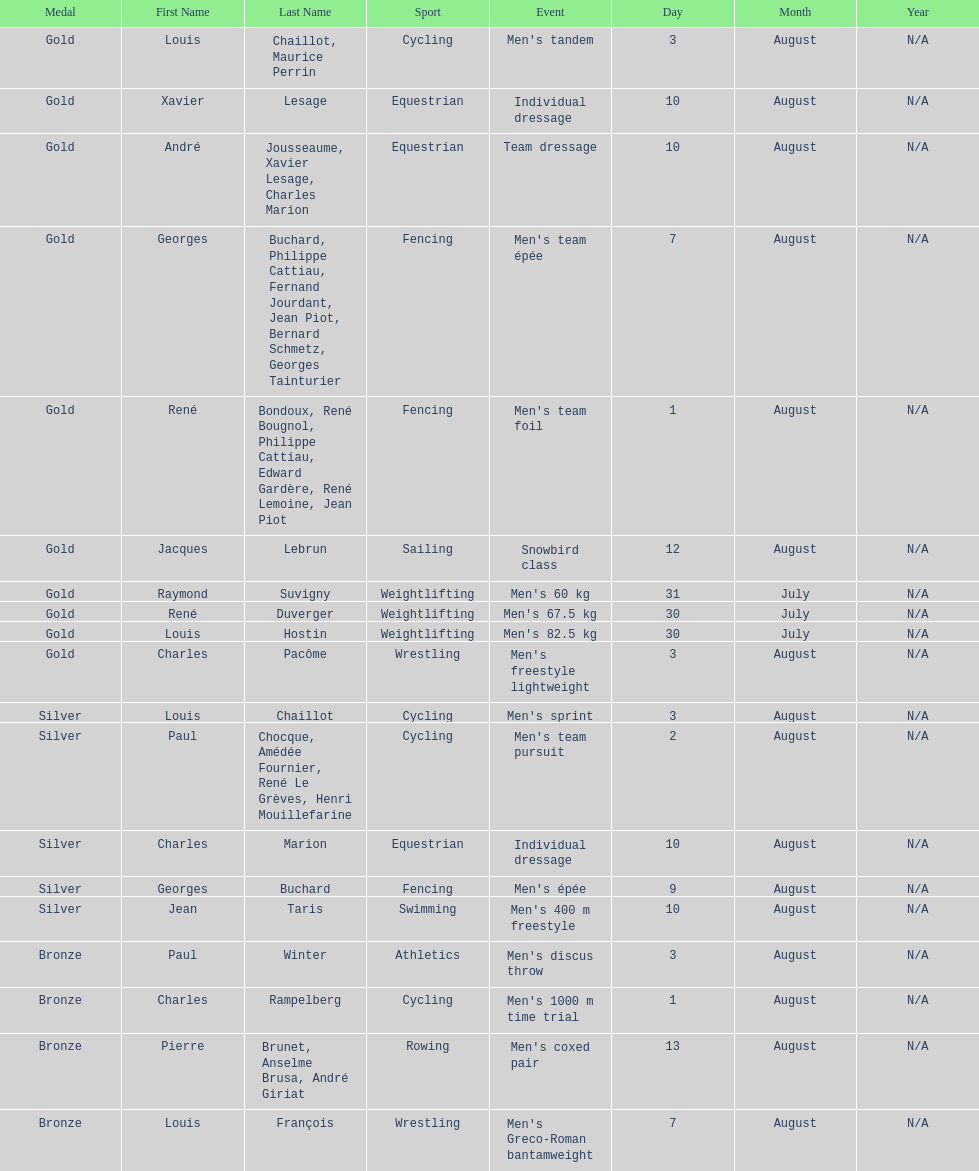Which event won the most medals? Cycling. 